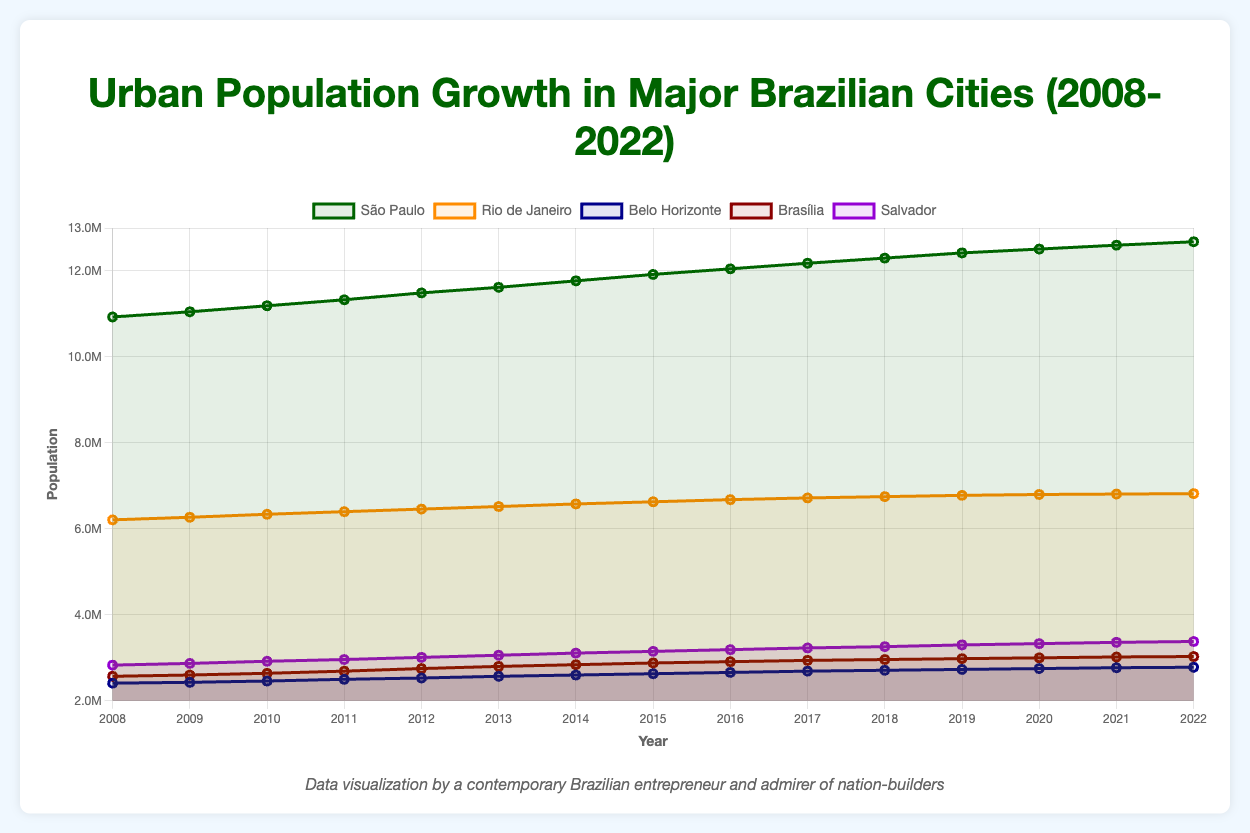What is the population difference between São Paulo and Rio de Janeiro in 2022? To calculate the population difference between São Paulo and Rio de Janeiro in 2022, subtract the population of Rio de Janeiro (6,820,000) from that of São Paulo (12,680,000). This results in 12,680,000 - 6,820,000 = 5,860,000.
Answer: 5,860,000 Which city showed the highest population growth between 2008 and 2022? By observing the line plot, note the highest vertical change. São Paulo grew from 10,930,000 in 2008 to 12,680,000 in 2022, totaling a growth of 1,750,000; other cities have smaller growths.
Answer: São Paulo Between 2008 and 2022, which city had the smallest increase in urban population? By comparing the changes in urban population for each city from 2008 to 2022, Rio de Janeiro's population increased from 6,210,000 to 6,820,000, a growth of only 610,000, which is the smallest among the cities listed.
Answer: Rio de Janeiro What was Brasília's population in 2010? Refer to the line representing Brasília and find the population value for the year 2010, which is indicated as 2,640,000 in the data.
Answer: 2,640,000 Compare the populations of Salvador and Belo Horizonte in 2022. Which one is larger? According to the data, Salvador's population in 2022 is 3,380,000, whereas Belo Horizonte's is 2,780,000. Thus, Salvador has a larger population in 2022.
Answer: Salvador How much did the population of Brasília increase from 2008 to 2022? To determine Brasília’s population increase from 2008 to 2022, subtract the 2008 population (2,570,000) from the 2022 population (3,030,000), giving an increase of 3,030,000 - 2,570,000 = 460,000.
Answer: 460,000 Which city had the highest population in 2015? Check the line plot for the highest data point in 2015. São Paulo has the highest population at 11,920,000 in 2015.
Answer: São Paulo What is the average population of Rio de Janeiro from 2008 to 2022? Sum the population values for Rio de Janeiro from 2008 to 2022 and divide by the number of years (15). The sum is 95,310,000, and the average is 95,310,000 / 15 = 6,354,000
Answer: 6,354,000 Which city had the sharpest increase in population from 2008 to 2011? Look for the steepest line segment between 2008 and 2011. Brasília's population increased from 2,570,000 to 2,690,000, showing a notable rise which is steeper compared to other cities.
Answer: Brasília 